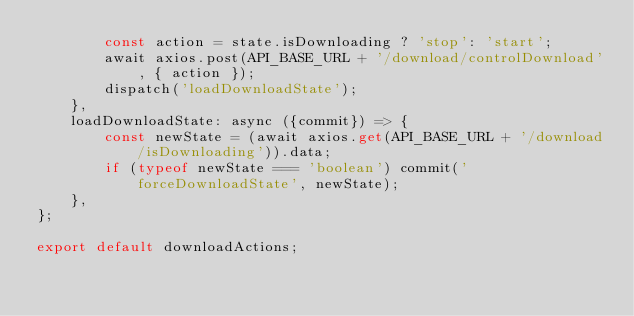<code> <loc_0><loc_0><loc_500><loc_500><_TypeScript_>		const action = state.isDownloading ? 'stop': 'start';
		await axios.post(API_BASE_URL + '/download/controlDownload', { action });
		dispatch('loadDownloadState');
	},
	loadDownloadState: async ({commit}) => {
		const newState = (await axios.get(API_BASE_URL + '/download/isDownloading')).data;
		if (typeof newState === 'boolean') commit('forceDownloadState', newState);
	},
};

export default downloadActions;

</code> 